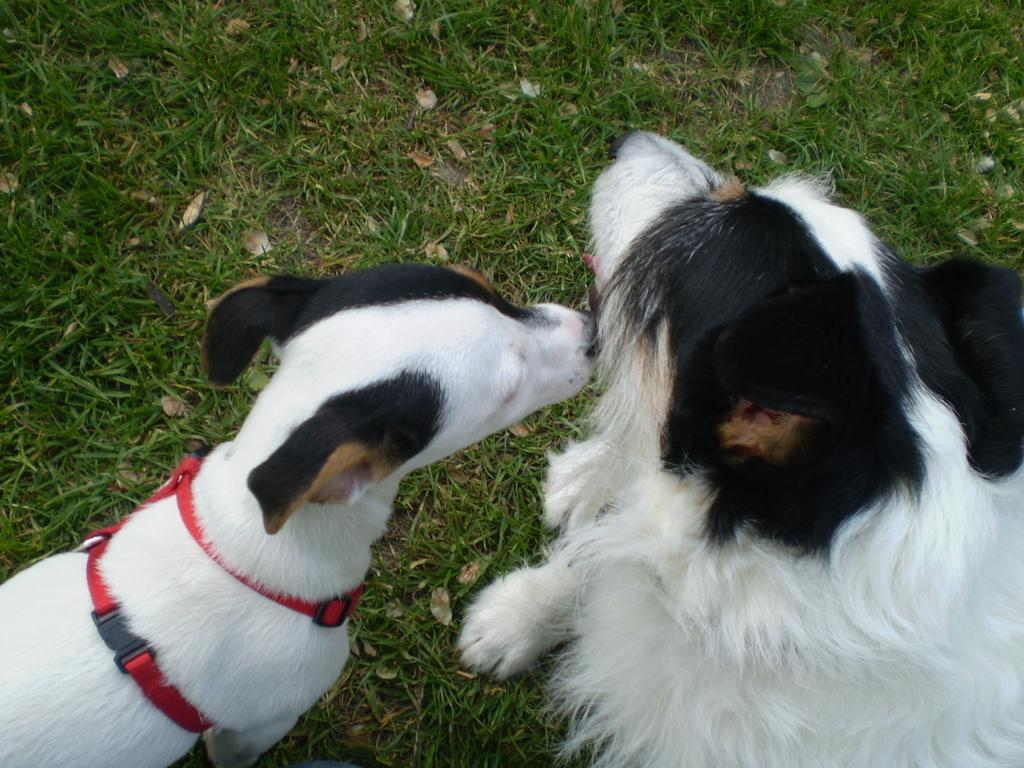How many dogs are in the image? There are two dogs in the image. What colors are the dogs? The dogs are black and white. Where are the dogs located in the image? The dogs are on the grass. What distinguishes one of the dogs from the other? One dog has a red belt. What type of flower is growing in the club in the image? There is no flower or club present in the image; it features two black and white dogs on the grass. 